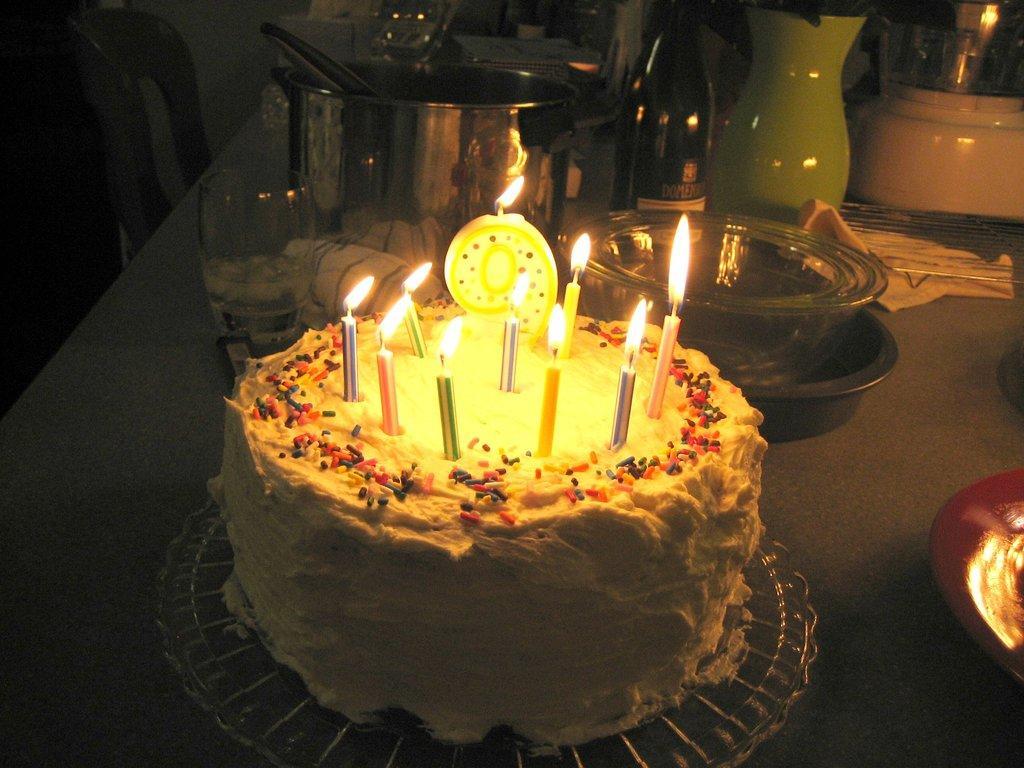Please provide a concise description of this image. In this image I can see a table and on the table I can see a cake with few candles on it, few glasses, a bottle and few other objects. I can see the dark background in which I can see a chair and few other objects. 